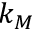Convert formula to latex. <formula><loc_0><loc_0><loc_500><loc_500>k _ { M }</formula> 